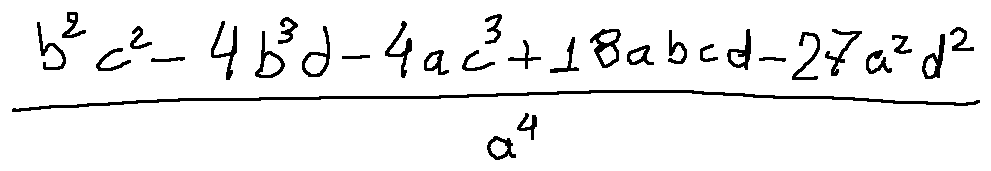Convert formula to latex. <formula><loc_0><loc_0><loc_500><loc_500>\frac { b ^ { 2 } c ^ { 2 } - 4 b ^ { 3 } d - 4 a c ^ { 3 } + 1 8 a b c d - 2 7 a ^ { 2 } d ^ { 2 } } { a ^ { 4 } }</formula> 